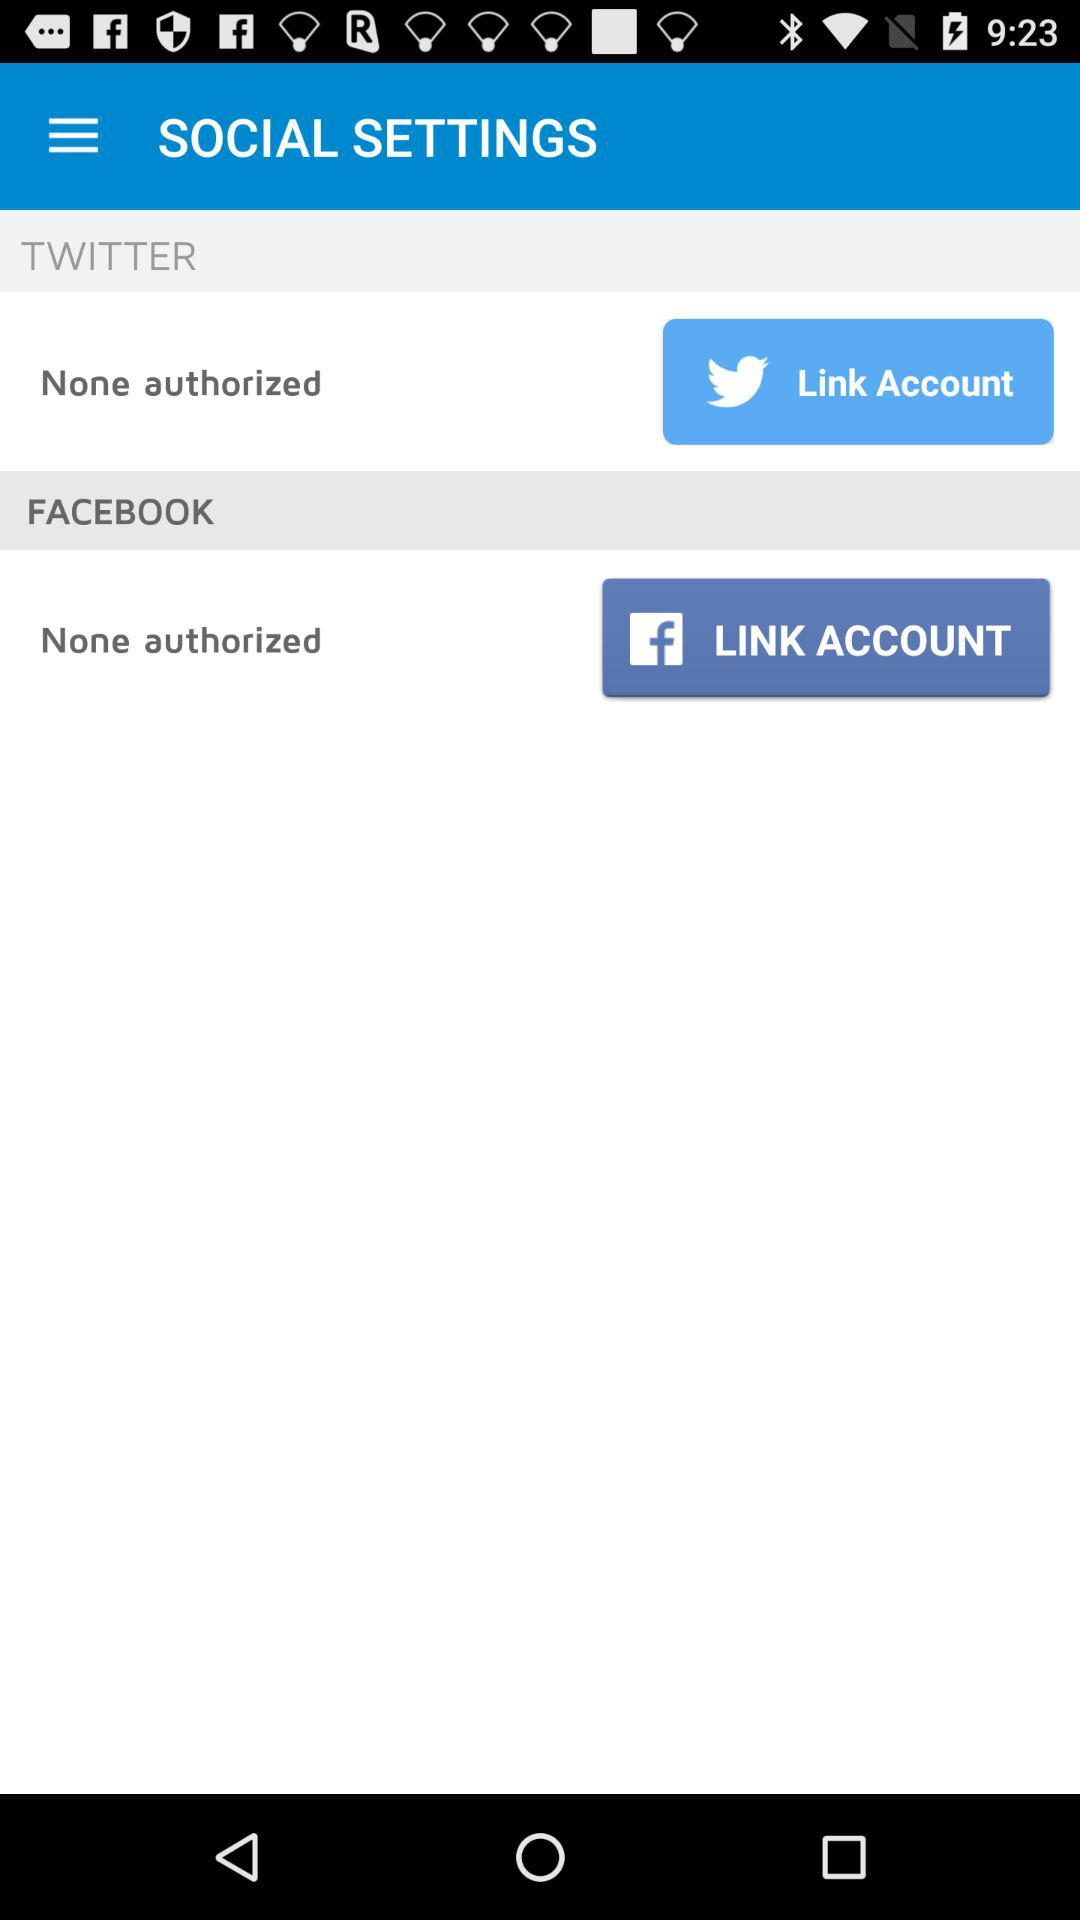How many social media accounts are not authorized?
Answer the question using a single word or phrase. 2 